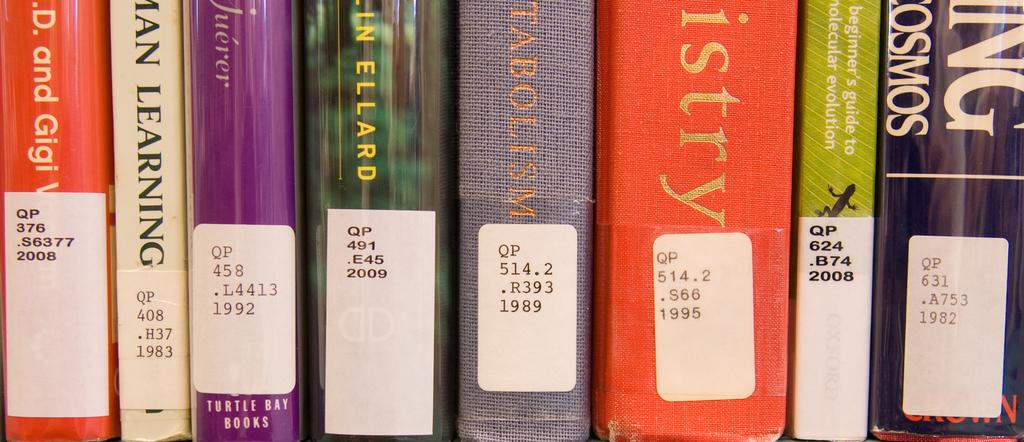Provide a one-sentence caption for the provided image. Several books are lined up next to each other and the first one on the left has a sticker on it that reads WP376.S63772008. 